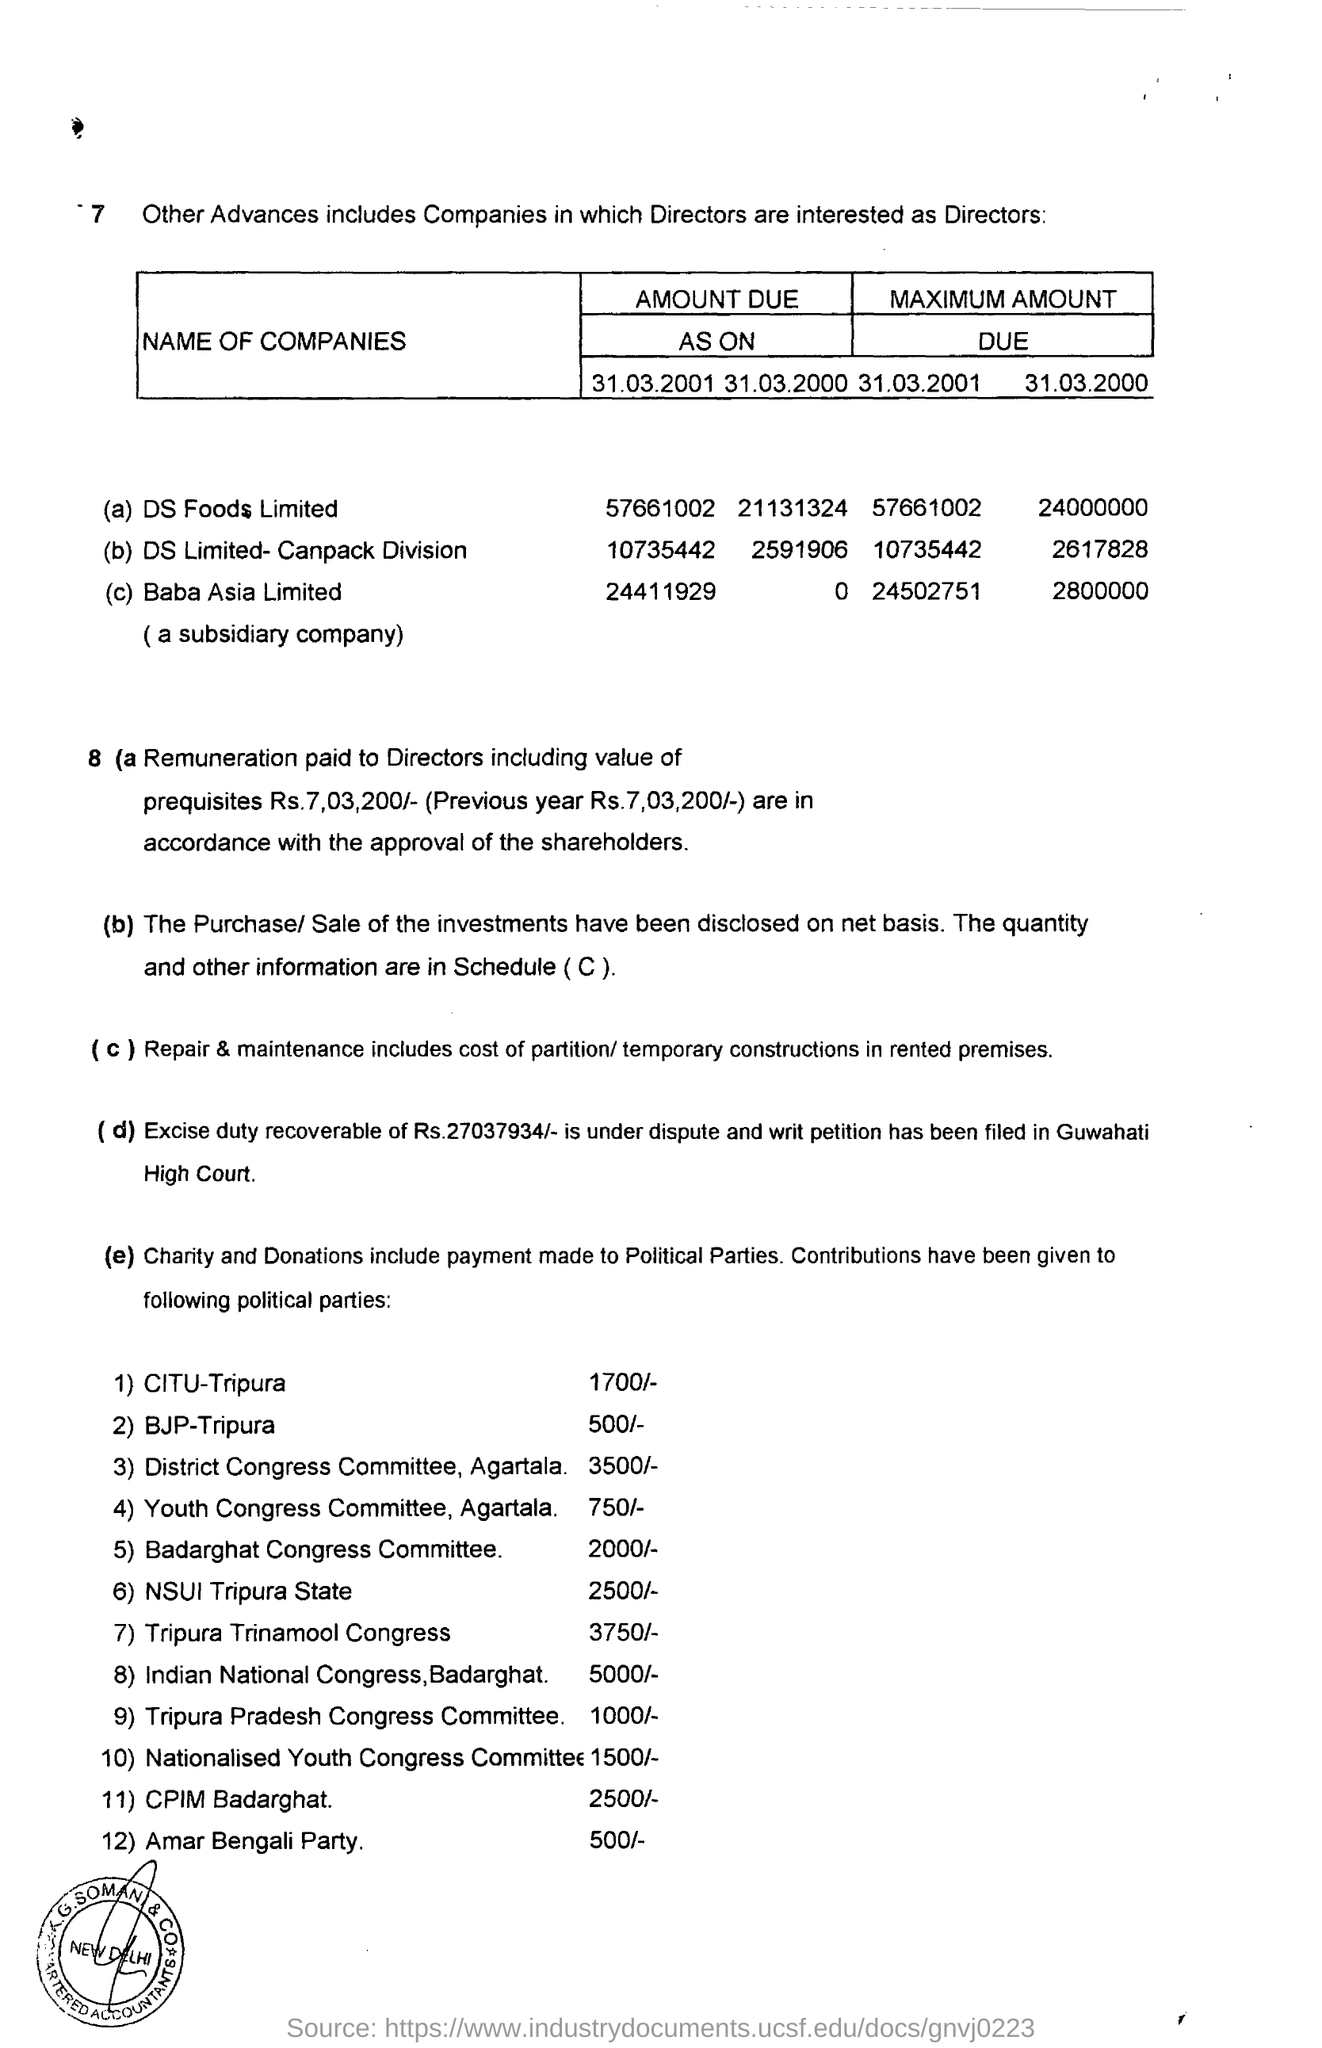For how much amount the dispute and writ petition filed?
Provide a short and direct response. Rs.27037934/-. In which court the dispute and writ petition is filled?
Offer a terse response. Guwahati High Court. How much amount is contributed to the BJP-Tripura ?
Ensure brevity in your answer.  500/-. 